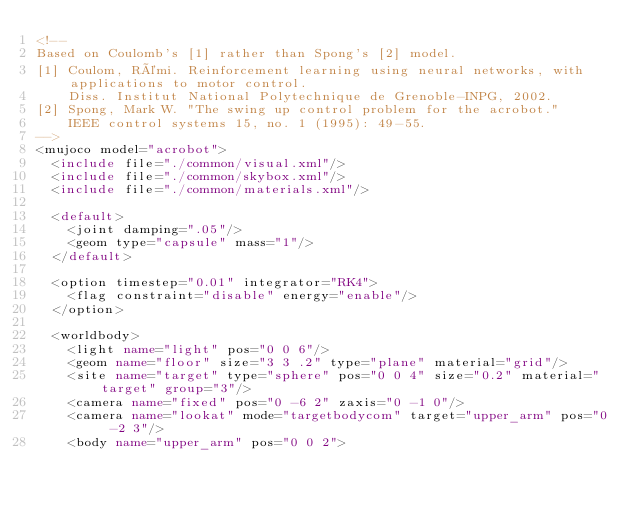Convert code to text. <code><loc_0><loc_0><loc_500><loc_500><_XML_><!--
Based on Coulomb's [1] rather than Spong's [2] model.
[1] Coulom, Rémi. Reinforcement learning using neural networks, with applications to motor control.
    Diss. Institut National Polytechnique de Grenoble-INPG, 2002.
[2] Spong, Mark W. "The swing up control problem for the acrobot."
    IEEE control systems 15, no. 1 (1995): 49-55.
-->
<mujoco model="acrobot">
  <include file="./common/visual.xml"/>
  <include file="./common/skybox.xml"/>
  <include file="./common/materials.xml"/>

  <default>
    <joint damping=".05"/>
    <geom type="capsule" mass="1"/>
  </default>

  <option timestep="0.01" integrator="RK4">
    <flag constraint="disable" energy="enable"/>
  </option>

  <worldbody>
    <light name="light" pos="0 0 6"/>
    <geom name="floor" size="3 3 .2" type="plane" material="grid"/>
    <site name="target" type="sphere" pos="0 0 4" size="0.2" material="target" group="3"/>
    <camera name="fixed" pos="0 -6 2" zaxis="0 -1 0"/>
    <camera name="lookat" mode="targetbodycom" target="upper_arm" pos="0 -2 3"/>
    <body name="upper_arm" pos="0 0 2"></code> 